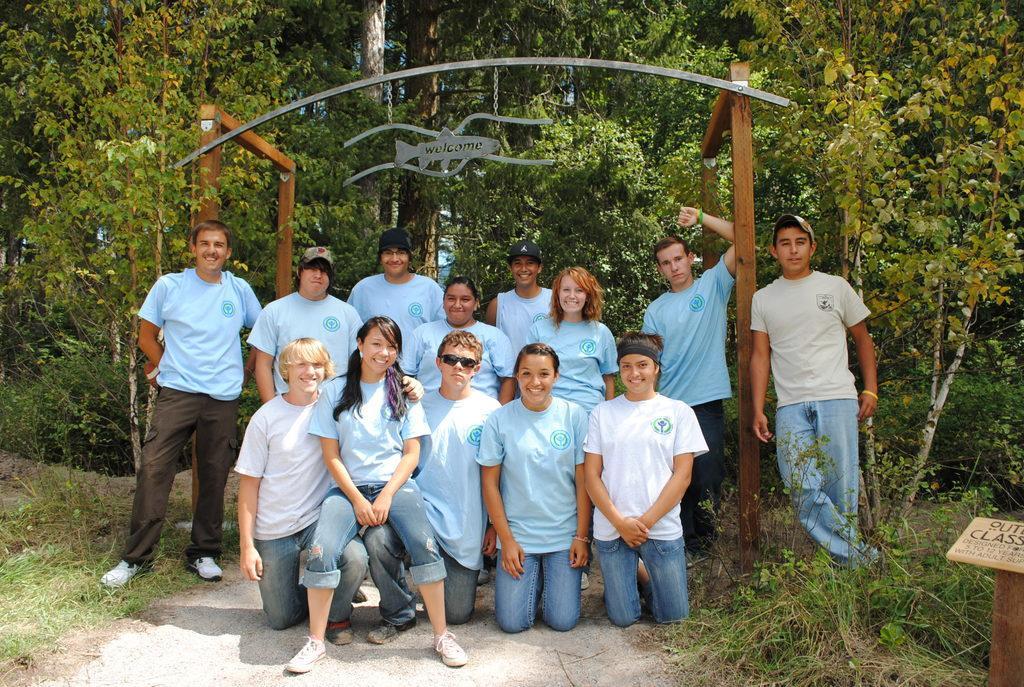Describe this image in one or two sentences. In this picture I can see the arch construction. I can see trees. I can see green grass. I can see a number of people with a smile on the surface. 